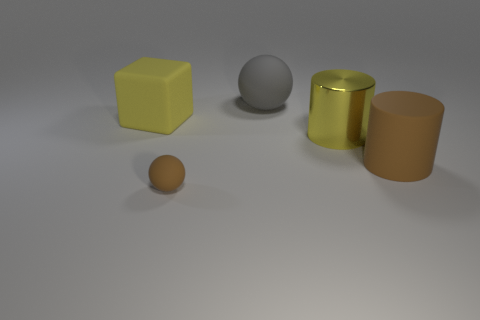Add 3 large rubber cylinders. How many objects exist? 8 Subtract all cylinders. How many objects are left? 3 Add 2 gray balls. How many gray balls are left? 3 Add 3 big yellow blocks. How many big yellow blocks exist? 4 Subtract 0 gray blocks. How many objects are left? 5 Subtract all tiny gray metal cylinders. Subtract all yellow things. How many objects are left? 3 